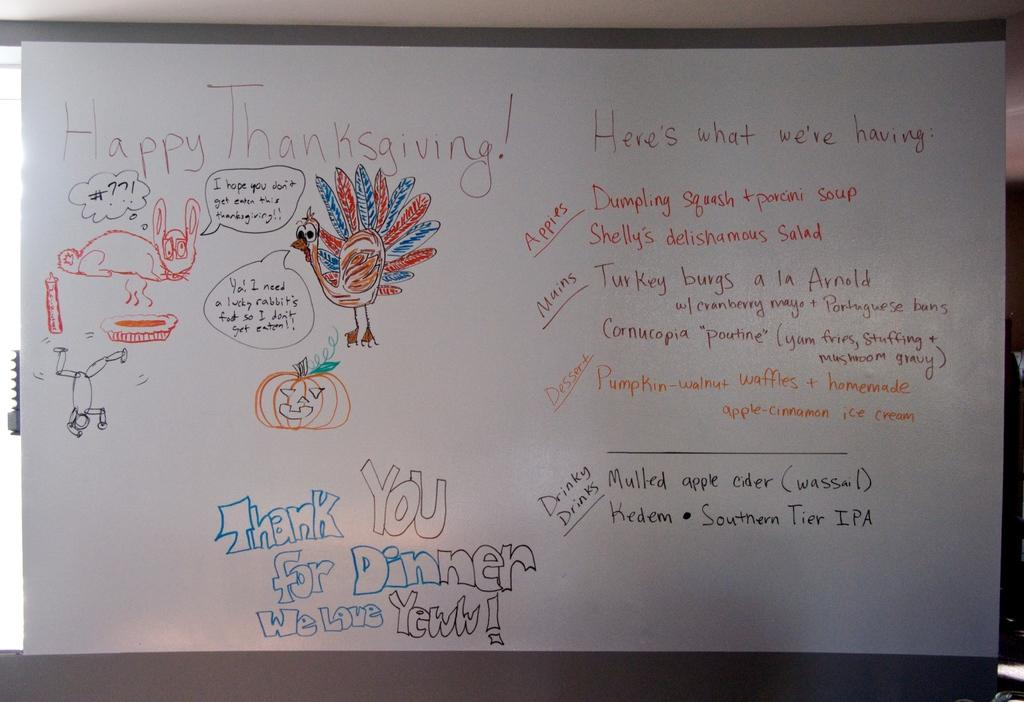<image>
Give a short and clear explanation of the subsequent image. A white board has "Happy Thanksgiving!" written on it. 